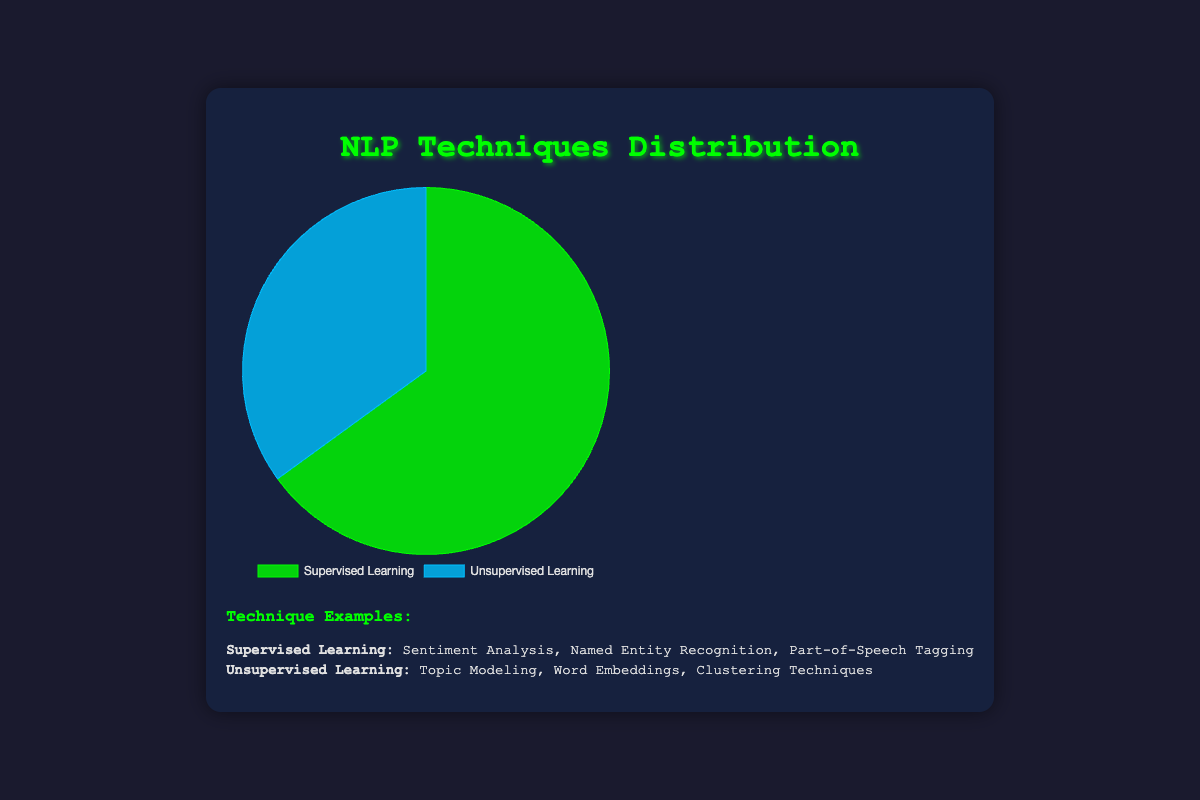What percentage of NLP techniques are unsupervised? The pie chart shows two categories: Supervised Learning and Unsupervised Learning. From the chart, it can be observed that Unsupervised Learning accounts for 35% of the total NLP techniques.
Answer: 35% Which NLP technique is more commonly used, supervised or unsupervised learning? The pie chart illustrates that Supervised Learning is used 65% of the time, whereas Unsupervised Learning is utilized 35% of the time. Therefore, Supervised Learning is more commonly used.
Answer: Supervised Learning What is the difference in percentage usage between supervised and unsupervised learning techniques? The pie chart shows the percentages for each category. Supervised Learning is 65%, and Unsupervised Learning is 35%. The difference can be calculated as 65% - 35%.
Answer: 30% What color represents Supervised Learning in the pie chart? Observing the pie chart, Supervised Learning is represented by the color green.
Answer: Green If a new NLP technique was added to the chart and it was an unsupervised approach that accounted for an additional 5% of usage, what would be the new percentage of unsupervised techniques? Initially, Unsupervised Learning accounts for 35% of the total. Adding another 5% would make 35% + 5%.
Answer: 40% What are three examples of techniques categorized under Supervised Learning in the chart? According to the additional information presented below the pie chart, examples of techniques under Supervised Learning include Sentiment Analysis, Named Entity Recognition, and Part-of-Speech Tagging.
Answer: Sentiment Analysis, Named Entity Recognition, Part-of-Speech Tagging How does the percentage of supervised learning techniques compare to that of unsupervised learning techniques? The chart provides the percentages: 65% for Supervised Learning and 35% for Unsupervised Learning. Supervised Learning is almost twice as prevalent as Unsupervised Learning because 65% is roughly double 35%.
Answer: Supervised Learning is nearly twice as prevalent Which category, Supervised or Unsupervised Learning, has fewer examples listed, and how many fewer examples are there? Supervised Learning lists Sentiment Analysis, Named Entity Recognition, and Part-of-Speech Tagging (3 examples). Unsupervised Learning includes Topic Modeling, Word Embeddings, and Clustering Techniques (3 examples). Both categories have an equal number of examples.
Answer: Equal number of examples What color represents Unsupervised Learning in the pie chart? Observing the pie chart, Unsupervised Learning is represented by the color blue.
Answer: Blue 